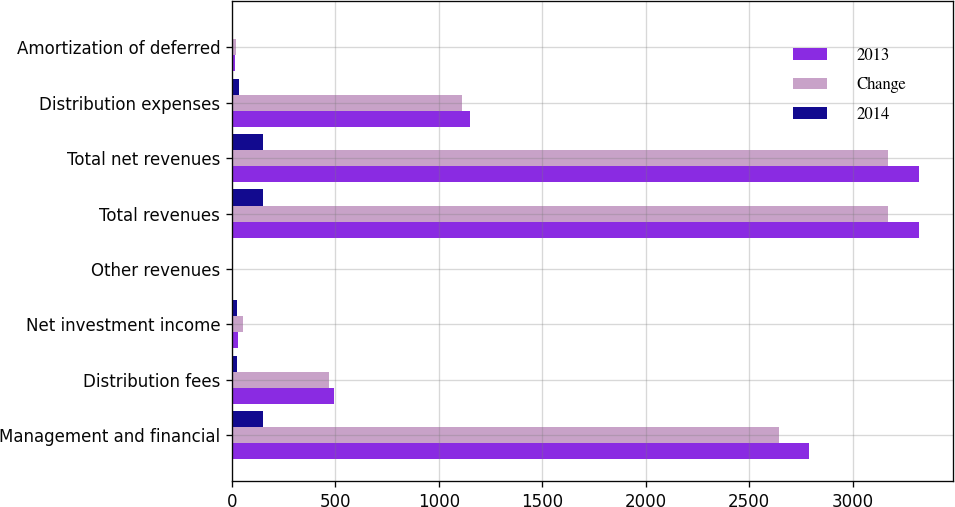<chart> <loc_0><loc_0><loc_500><loc_500><stacked_bar_chart><ecel><fcel>Management and financial<fcel>Distribution fees<fcel>Net investment income<fcel>Other revenues<fcel>Total revenues<fcel>Total net revenues<fcel>Distribution expenses<fcel>Amortization of deferred<nl><fcel>2013<fcel>2791<fcel>493<fcel>30<fcel>6<fcel>3320<fcel>3320<fcel>1148<fcel>15<nl><fcel>Change<fcel>2643<fcel>469<fcel>54<fcel>5<fcel>3171<fcel>3169<fcel>1112<fcel>17<nl><fcel>2014<fcel>148<fcel>24<fcel>24<fcel>1<fcel>149<fcel>151<fcel>36<fcel>2<nl></chart> 